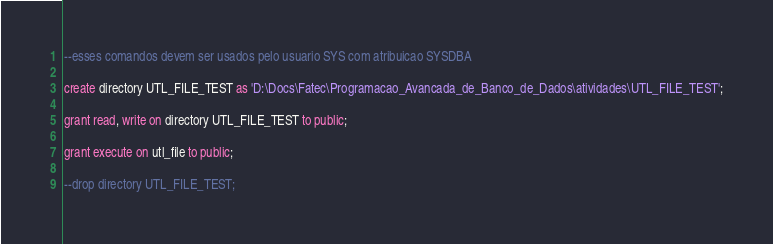<code> <loc_0><loc_0><loc_500><loc_500><_SQL_>--esses comandos devem ser usados pelo usuario SYS com atribuicao SYSDBA

create directory UTL_FILE_TEST as 'D:\Docs\Fatec\Programacao_Avancada_de_Banco_de_Dados\atividades\UTL_FILE_TEST';

grant read, write on directory UTL_FILE_TEST to public;

grant execute on utl_file to public;

--drop directory UTL_FILE_TEST;
</code> 